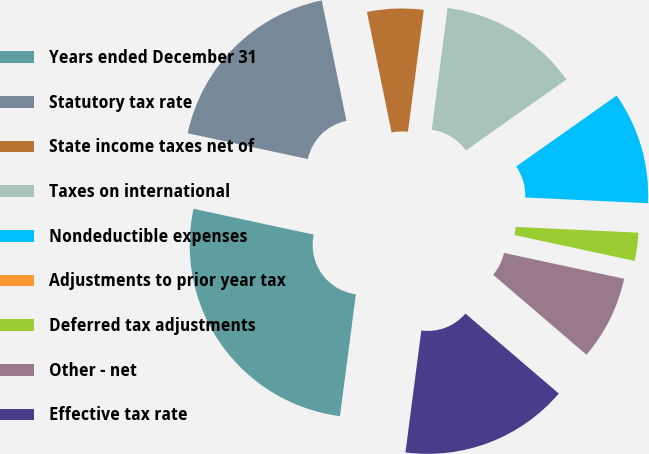<chart> <loc_0><loc_0><loc_500><loc_500><pie_chart><fcel>Years ended December 31<fcel>Statutory tax rate<fcel>State income taxes net of<fcel>Taxes on international<fcel>Nondeductible expenses<fcel>Adjustments to prior year tax<fcel>Deferred tax adjustments<fcel>Other - net<fcel>Effective tax rate<nl><fcel>26.31%<fcel>18.42%<fcel>5.27%<fcel>13.16%<fcel>10.53%<fcel>0.0%<fcel>2.63%<fcel>7.9%<fcel>15.79%<nl></chart> 